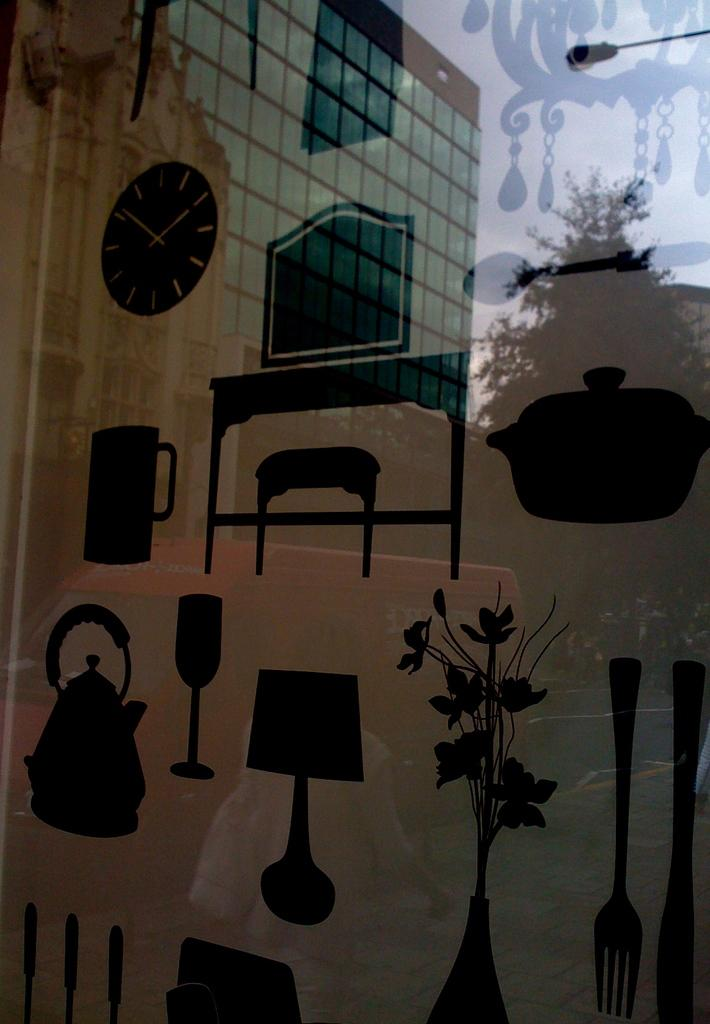What type of object is made of glass in the image? There is a glass object in the image. What can be seen inside the glass object? There are objects inside the glass. What is reflected on the glass object? The reflection of a building and a tree is visible on the glass. How many kittens are playing with sticks in the image? There are no kittens or sticks present in the image. 